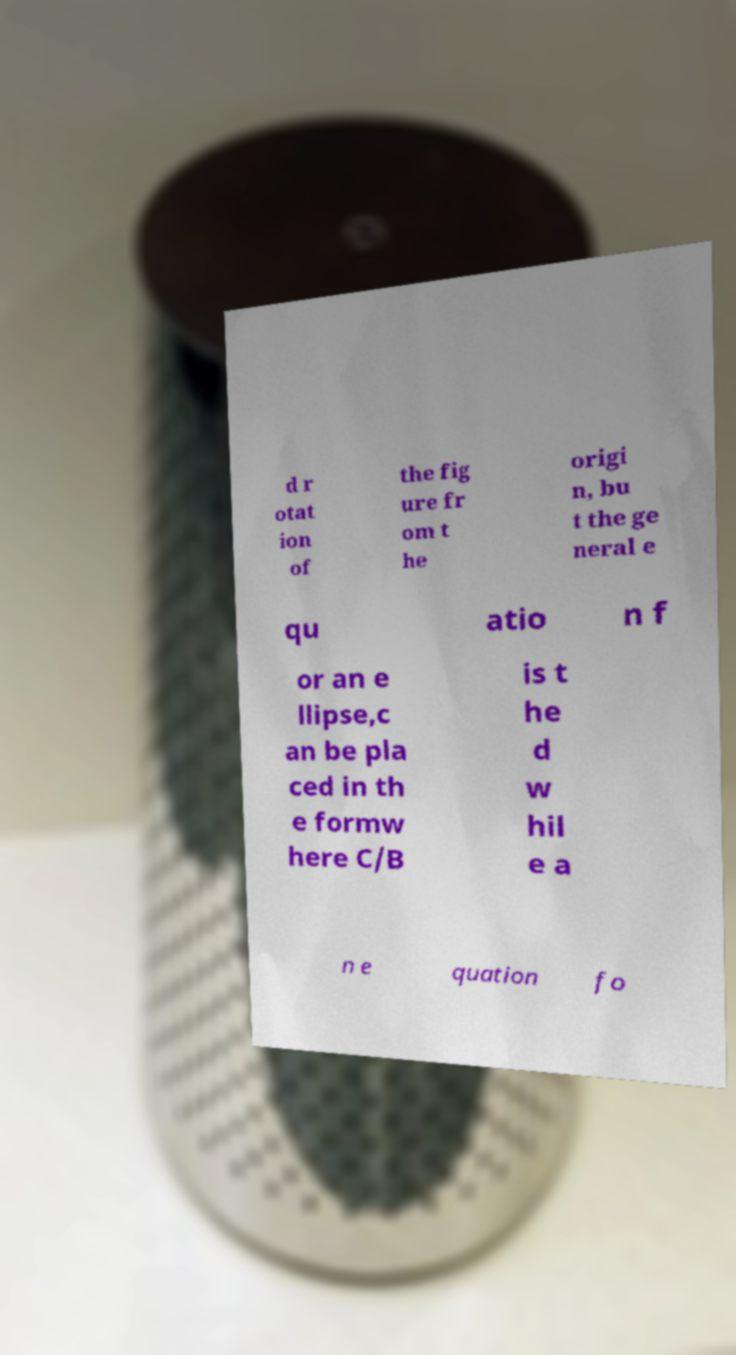What messages or text are displayed in this image? I need them in a readable, typed format. d r otat ion of the fig ure fr om t he origi n, bu t the ge neral e qu atio n f or an e llipse,c an be pla ced in th e formw here C/B is t he d w hil e a n e quation fo 